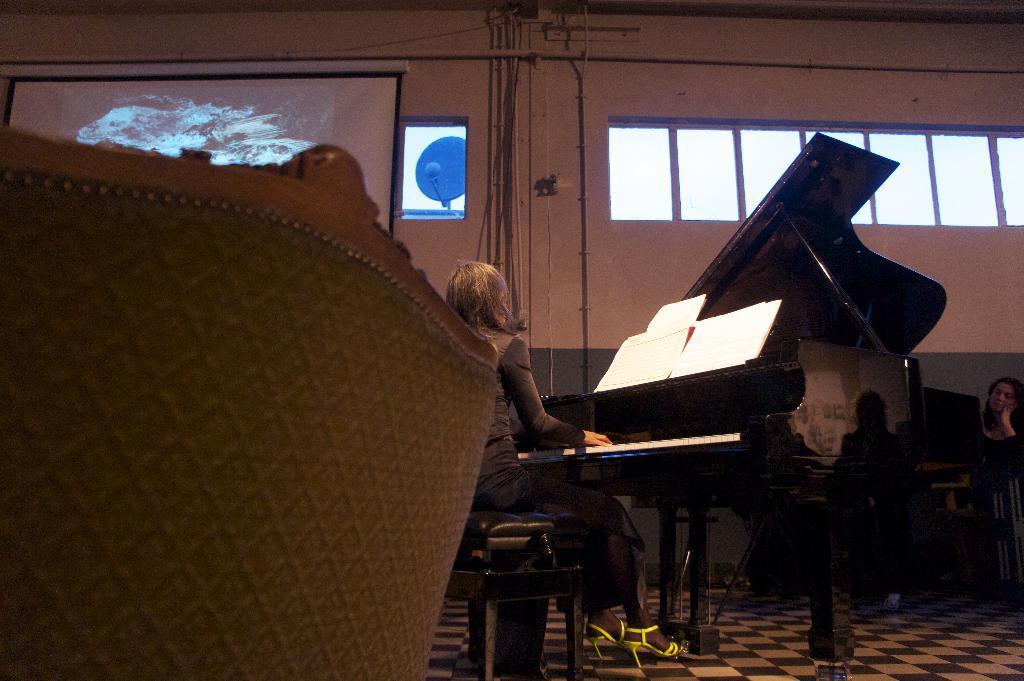Could you give a brief overview of what you see in this image? In this picture a lady who is dressed in black is playing piano , on top of which books are placed. We can also observe a sofa to the left side of the image. In the background there are few glass windows and projector screen and few pipes. There are also few people sitting on the either side of the piano. 